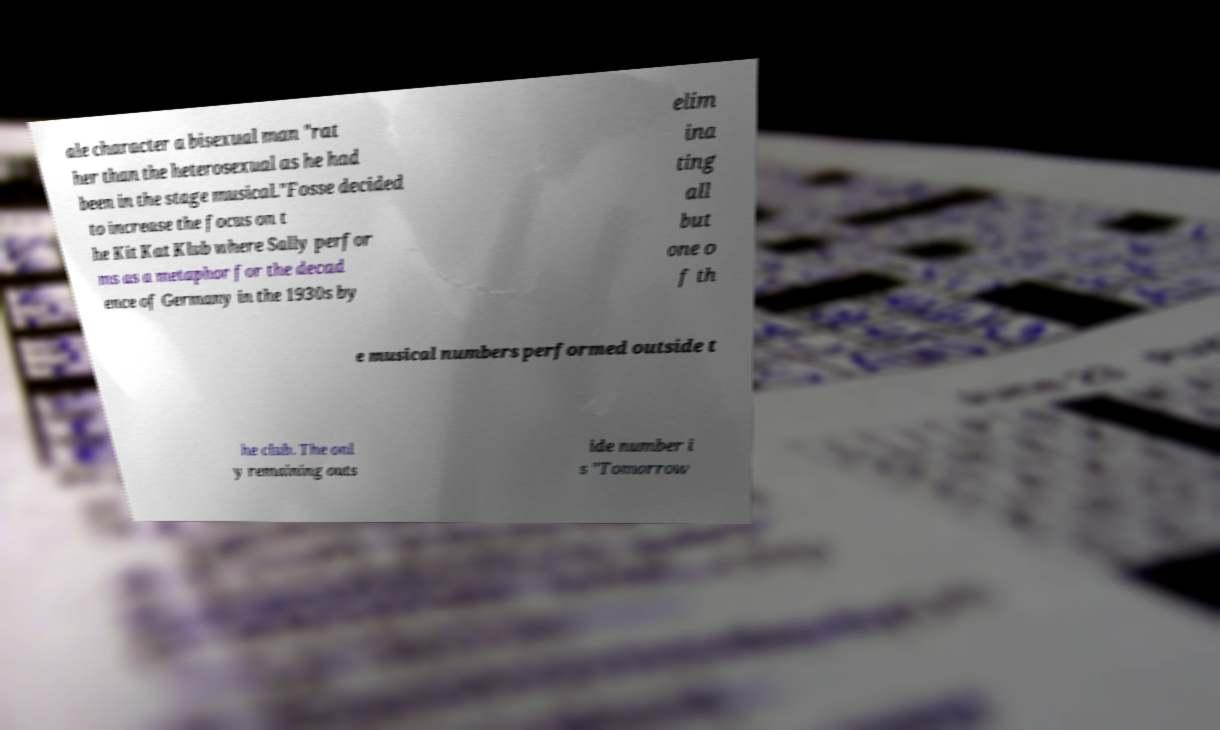I need the written content from this picture converted into text. Can you do that? ale character a bisexual man "rat her than the heterosexual as he had been in the stage musical."Fosse decided to increase the focus on t he Kit Kat Klub where Sally perfor ms as a metaphor for the decad ence of Germany in the 1930s by elim ina ting all but one o f th e musical numbers performed outside t he club. The onl y remaining outs ide number i s "Tomorrow 